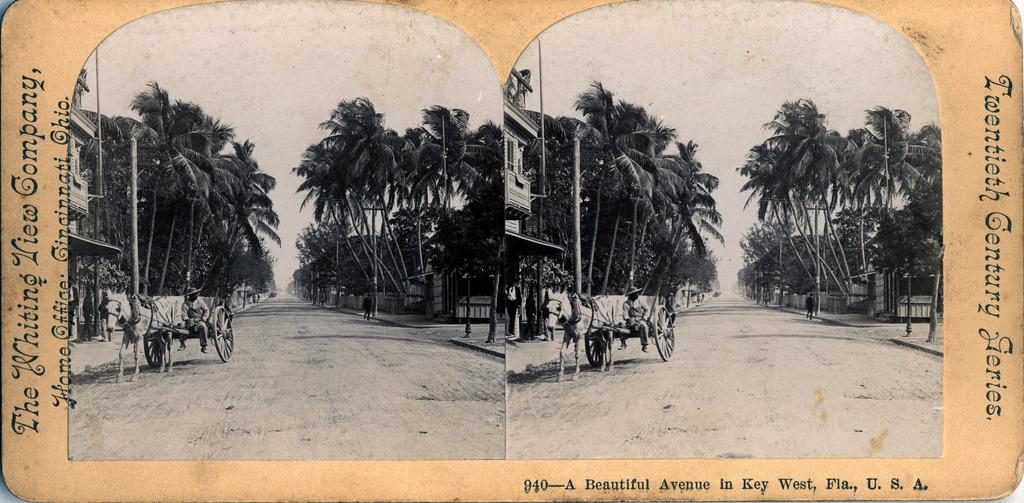Describe this image in one or two sentences. This image looks like a photo frame in which I can see two horse carts, two persons on the road, text, trees, fence, buildings, two persons are walking and the sky. 